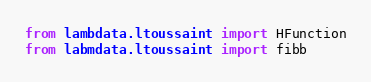<code> <loc_0><loc_0><loc_500><loc_500><_Python_>
from lambdata.ltoussaint import HFunction
from labmdata.ltoussaint import fibb
</code> 